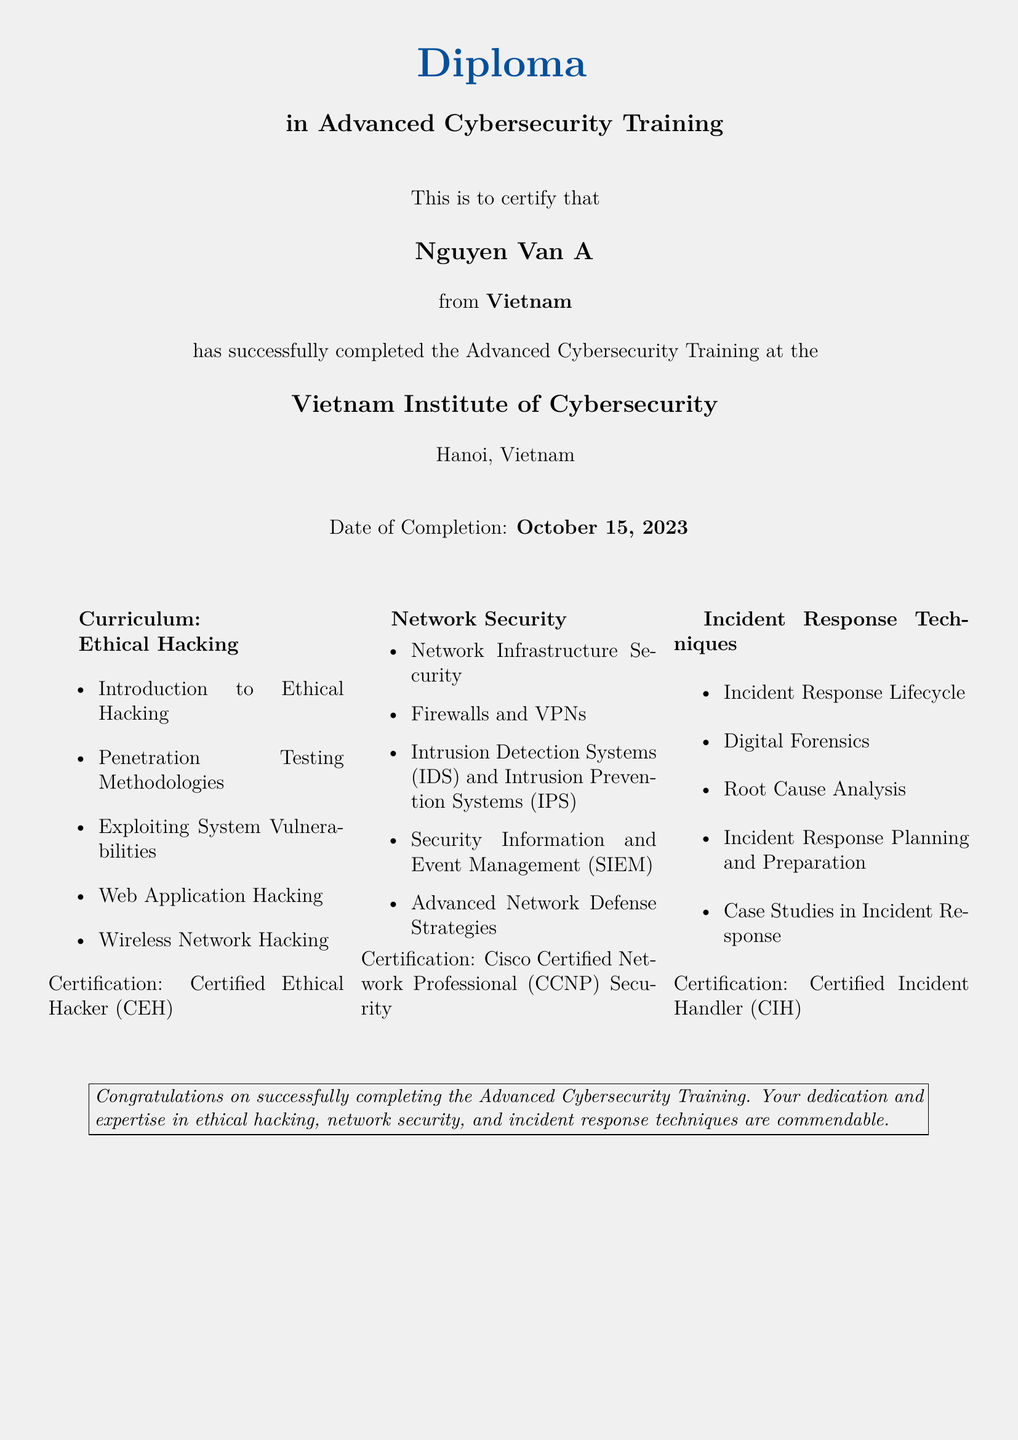What is the title of the diploma? The title of the diploma is mentioned at the top of the document as the certification awarded upon completion of the program.
Answer: Diploma in Advanced Cybersecurity Training Who is the recipient of the diploma? The recipient's name is clearly stated in the document, highlighting the individual who completed the training program.
Answer: Nguyen Van A What is the date of completion? The date is explicitly mentioned in the document, indicating when the training was successfully completed.
Answer: October 15, 2023 Where was the diploma awarded? The location of the awarding institution is stated, identifying the place associated with the credential.
Answer: Hanoi, Vietnam What is one of the certifications mentioned in the curriculum? The curriculum section lists several certifications related to the training topics.
Answer: Certified Ethical Hacker (CEH) What are the three main areas of focus in the curriculum? The document categorizes the curriculum into three distinct areas, which gives insight into the training subjects.
Answer: Ethical Hacking, Network Security, Incident Response Techniques How many columns are in the curriculum section? The format of the curriculum allows for a specific layout, visually dividing the content into distinct parts.
Answer: 3 Which institute provided the training? The organization responsible for delivering the training program is mentioned in the document.
Answer: Vietnam Institute of Cybersecurity 